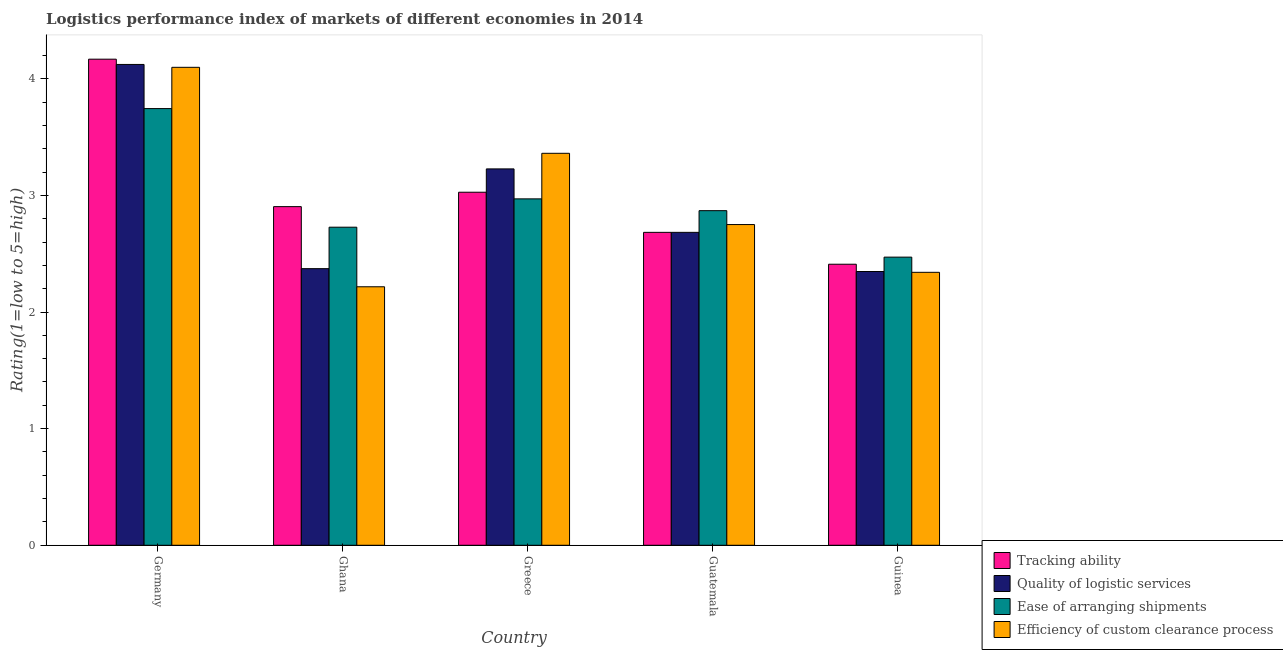How many different coloured bars are there?
Offer a very short reply. 4. Are the number of bars on each tick of the X-axis equal?
Offer a very short reply. Yes. How many bars are there on the 2nd tick from the left?
Give a very brief answer. 4. What is the label of the 5th group of bars from the left?
Your answer should be very brief. Guinea. In how many cases, is the number of bars for a given country not equal to the number of legend labels?
Offer a very short reply. 0. What is the lpi rating of efficiency of custom clearance process in Ghana?
Keep it short and to the point. 2.22. Across all countries, what is the maximum lpi rating of tracking ability?
Your response must be concise. 4.17. Across all countries, what is the minimum lpi rating of quality of logistic services?
Your answer should be compact. 2.35. What is the total lpi rating of quality of logistic services in the graph?
Give a very brief answer. 14.75. What is the difference between the lpi rating of tracking ability in Germany and that in Guatemala?
Give a very brief answer. 1.48. What is the difference between the lpi rating of ease of arranging shipments in Germany and the lpi rating of efficiency of custom clearance process in Guinea?
Your answer should be very brief. 1.4. What is the average lpi rating of quality of logistic services per country?
Provide a succinct answer. 2.95. What is the difference between the lpi rating of ease of arranging shipments and lpi rating of tracking ability in Guinea?
Provide a succinct answer. 0.06. What is the ratio of the lpi rating of ease of arranging shipments in Greece to that in Guinea?
Give a very brief answer. 1.2. Is the lpi rating of tracking ability in Germany less than that in Guinea?
Ensure brevity in your answer.  No. Is the difference between the lpi rating of efficiency of custom clearance process in Germany and Guinea greater than the difference between the lpi rating of quality of logistic services in Germany and Guinea?
Provide a succinct answer. No. What is the difference between the highest and the second highest lpi rating of ease of arranging shipments?
Offer a terse response. 0.77. What is the difference between the highest and the lowest lpi rating of quality of logistic services?
Offer a terse response. 1.78. In how many countries, is the lpi rating of efficiency of custom clearance process greater than the average lpi rating of efficiency of custom clearance process taken over all countries?
Give a very brief answer. 2. Is the sum of the lpi rating of quality of logistic services in Guatemala and Guinea greater than the maximum lpi rating of ease of arranging shipments across all countries?
Give a very brief answer. Yes. Is it the case that in every country, the sum of the lpi rating of quality of logistic services and lpi rating of ease of arranging shipments is greater than the sum of lpi rating of efficiency of custom clearance process and lpi rating of tracking ability?
Your response must be concise. No. What does the 1st bar from the left in Greece represents?
Give a very brief answer. Tracking ability. What does the 1st bar from the right in Greece represents?
Your response must be concise. Efficiency of custom clearance process. Is it the case that in every country, the sum of the lpi rating of tracking ability and lpi rating of quality of logistic services is greater than the lpi rating of ease of arranging shipments?
Ensure brevity in your answer.  Yes. How many bars are there?
Provide a short and direct response. 20. Are all the bars in the graph horizontal?
Provide a succinct answer. No. How many countries are there in the graph?
Your response must be concise. 5. Are the values on the major ticks of Y-axis written in scientific E-notation?
Keep it short and to the point. No. Where does the legend appear in the graph?
Offer a very short reply. Bottom right. How many legend labels are there?
Offer a very short reply. 4. What is the title of the graph?
Make the answer very short. Logistics performance index of markets of different economies in 2014. What is the label or title of the Y-axis?
Your response must be concise. Rating(1=low to 5=high). What is the Rating(1=low to 5=high) of Tracking ability in Germany?
Your answer should be compact. 4.17. What is the Rating(1=low to 5=high) of Quality of logistic services in Germany?
Provide a succinct answer. 4.12. What is the Rating(1=low to 5=high) of Ease of arranging shipments in Germany?
Offer a very short reply. 3.74. What is the Rating(1=low to 5=high) of Efficiency of custom clearance process in Germany?
Provide a succinct answer. 4.1. What is the Rating(1=low to 5=high) in Tracking ability in Ghana?
Provide a short and direct response. 2.9. What is the Rating(1=low to 5=high) in Quality of logistic services in Ghana?
Ensure brevity in your answer.  2.37. What is the Rating(1=low to 5=high) of Ease of arranging shipments in Ghana?
Your answer should be very brief. 2.73. What is the Rating(1=low to 5=high) of Efficiency of custom clearance process in Ghana?
Provide a succinct answer. 2.22. What is the Rating(1=low to 5=high) of Tracking ability in Greece?
Offer a very short reply. 3.03. What is the Rating(1=low to 5=high) of Quality of logistic services in Greece?
Give a very brief answer. 3.23. What is the Rating(1=low to 5=high) of Ease of arranging shipments in Greece?
Your answer should be compact. 2.97. What is the Rating(1=low to 5=high) in Efficiency of custom clearance process in Greece?
Offer a very short reply. 3.36. What is the Rating(1=low to 5=high) in Tracking ability in Guatemala?
Give a very brief answer. 2.68. What is the Rating(1=low to 5=high) of Quality of logistic services in Guatemala?
Provide a short and direct response. 2.68. What is the Rating(1=low to 5=high) of Ease of arranging shipments in Guatemala?
Offer a very short reply. 2.87. What is the Rating(1=low to 5=high) of Efficiency of custom clearance process in Guatemala?
Keep it short and to the point. 2.75. What is the Rating(1=low to 5=high) of Tracking ability in Guinea?
Your response must be concise. 2.41. What is the Rating(1=low to 5=high) of Quality of logistic services in Guinea?
Ensure brevity in your answer.  2.35. What is the Rating(1=low to 5=high) of Ease of arranging shipments in Guinea?
Ensure brevity in your answer.  2.47. What is the Rating(1=low to 5=high) of Efficiency of custom clearance process in Guinea?
Your response must be concise. 2.34. Across all countries, what is the maximum Rating(1=low to 5=high) of Tracking ability?
Make the answer very short. 4.17. Across all countries, what is the maximum Rating(1=low to 5=high) in Quality of logistic services?
Offer a very short reply. 4.12. Across all countries, what is the maximum Rating(1=low to 5=high) in Ease of arranging shipments?
Your response must be concise. 3.74. Across all countries, what is the maximum Rating(1=low to 5=high) of Efficiency of custom clearance process?
Provide a short and direct response. 4.1. Across all countries, what is the minimum Rating(1=low to 5=high) of Tracking ability?
Give a very brief answer. 2.41. Across all countries, what is the minimum Rating(1=low to 5=high) in Quality of logistic services?
Keep it short and to the point. 2.35. Across all countries, what is the minimum Rating(1=low to 5=high) of Ease of arranging shipments?
Offer a terse response. 2.47. Across all countries, what is the minimum Rating(1=low to 5=high) of Efficiency of custom clearance process?
Your answer should be very brief. 2.22. What is the total Rating(1=low to 5=high) in Tracking ability in the graph?
Your answer should be very brief. 15.19. What is the total Rating(1=low to 5=high) of Quality of logistic services in the graph?
Give a very brief answer. 14.75. What is the total Rating(1=low to 5=high) in Ease of arranging shipments in the graph?
Your response must be concise. 14.78. What is the total Rating(1=low to 5=high) in Efficiency of custom clearance process in the graph?
Offer a terse response. 14.77. What is the difference between the Rating(1=low to 5=high) of Tracking ability in Germany and that in Ghana?
Give a very brief answer. 1.26. What is the difference between the Rating(1=low to 5=high) of Quality of logistic services in Germany and that in Ghana?
Your answer should be compact. 1.75. What is the difference between the Rating(1=low to 5=high) in Ease of arranging shipments in Germany and that in Ghana?
Offer a terse response. 1.02. What is the difference between the Rating(1=low to 5=high) in Efficiency of custom clearance process in Germany and that in Ghana?
Your answer should be compact. 1.88. What is the difference between the Rating(1=low to 5=high) in Tracking ability in Germany and that in Greece?
Your answer should be compact. 1.14. What is the difference between the Rating(1=low to 5=high) in Quality of logistic services in Germany and that in Greece?
Provide a succinct answer. 0.9. What is the difference between the Rating(1=low to 5=high) of Ease of arranging shipments in Germany and that in Greece?
Offer a very short reply. 0.77. What is the difference between the Rating(1=low to 5=high) in Efficiency of custom clearance process in Germany and that in Greece?
Provide a succinct answer. 0.74. What is the difference between the Rating(1=low to 5=high) in Tracking ability in Germany and that in Guatemala?
Make the answer very short. 1.48. What is the difference between the Rating(1=low to 5=high) in Quality of logistic services in Germany and that in Guatemala?
Your response must be concise. 1.44. What is the difference between the Rating(1=low to 5=high) in Ease of arranging shipments in Germany and that in Guatemala?
Give a very brief answer. 0.88. What is the difference between the Rating(1=low to 5=high) in Efficiency of custom clearance process in Germany and that in Guatemala?
Provide a succinct answer. 1.35. What is the difference between the Rating(1=low to 5=high) of Tracking ability in Germany and that in Guinea?
Keep it short and to the point. 1.76. What is the difference between the Rating(1=low to 5=high) of Quality of logistic services in Germany and that in Guinea?
Provide a succinct answer. 1.78. What is the difference between the Rating(1=low to 5=high) of Ease of arranging shipments in Germany and that in Guinea?
Give a very brief answer. 1.27. What is the difference between the Rating(1=low to 5=high) in Efficiency of custom clearance process in Germany and that in Guinea?
Offer a terse response. 1.76. What is the difference between the Rating(1=low to 5=high) of Tracking ability in Ghana and that in Greece?
Ensure brevity in your answer.  -0.12. What is the difference between the Rating(1=low to 5=high) in Quality of logistic services in Ghana and that in Greece?
Offer a very short reply. -0.86. What is the difference between the Rating(1=low to 5=high) of Ease of arranging shipments in Ghana and that in Greece?
Your answer should be compact. -0.24. What is the difference between the Rating(1=low to 5=high) in Efficiency of custom clearance process in Ghana and that in Greece?
Your answer should be very brief. -1.14. What is the difference between the Rating(1=low to 5=high) in Tracking ability in Ghana and that in Guatemala?
Your response must be concise. 0.22. What is the difference between the Rating(1=low to 5=high) in Quality of logistic services in Ghana and that in Guatemala?
Provide a succinct answer. -0.31. What is the difference between the Rating(1=low to 5=high) of Ease of arranging shipments in Ghana and that in Guatemala?
Give a very brief answer. -0.14. What is the difference between the Rating(1=low to 5=high) in Efficiency of custom clearance process in Ghana and that in Guatemala?
Provide a succinct answer. -0.53. What is the difference between the Rating(1=low to 5=high) of Tracking ability in Ghana and that in Guinea?
Your answer should be compact. 0.49. What is the difference between the Rating(1=low to 5=high) in Quality of logistic services in Ghana and that in Guinea?
Your response must be concise. 0.02. What is the difference between the Rating(1=low to 5=high) of Ease of arranging shipments in Ghana and that in Guinea?
Your response must be concise. 0.26. What is the difference between the Rating(1=low to 5=high) of Efficiency of custom clearance process in Ghana and that in Guinea?
Ensure brevity in your answer.  -0.12. What is the difference between the Rating(1=low to 5=high) of Tracking ability in Greece and that in Guatemala?
Provide a short and direct response. 0.34. What is the difference between the Rating(1=low to 5=high) of Quality of logistic services in Greece and that in Guatemala?
Offer a terse response. 0.54. What is the difference between the Rating(1=low to 5=high) of Ease of arranging shipments in Greece and that in Guatemala?
Ensure brevity in your answer.  0.1. What is the difference between the Rating(1=low to 5=high) of Efficiency of custom clearance process in Greece and that in Guatemala?
Your response must be concise. 0.61. What is the difference between the Rating(1=low to 5=high) in Tracking ability in Greece and that in Guinea?
Make the answer very short. 0.62. What is the difference between the Rating(1=low to 5=high) of Quality of logistic services in Greece and that in Guinea?
Your response must be concise. 0.88. What is the difference between the Rating(1=low to 5=high) in Ease of arranging shipments in Greece and that in Guinea?
Your response must be concise. 0.5. What is the difference between the Rating(1=low to 5=high) of Efficiency of custom clearance process in Greece and that in Guinea?
Offer a terse response. 1.02. What is the difference between the Rating(1=low to 5=high) in Tracking ability in Guatemala and that in Guinea?
Your answer should be compact. 0.27. What is the difference between the Rating(1=low to 5=high) of Quality of logistic services in Guatemala and that in Guinea?
Your response must be concise. 0.34. What is the difference between the Rating(1=low to 5=high) in Ease of arranging shipments in Guatemala and that in Guinea?
Provide a succinct answer. 0.4. What is the difference between the Rating(1=low to 5=high) in Efficiency of custom clearance process in Guatemala and that in Guinea?
Offer a terse response. 0.41. What is the difference between the Rating(1=low to 5=high) in Tracking ability in Germany and the Rating(1=low to 5=high) in Quality of logistic services in Ghana?
Provide a succinct answer. 1.8. What is the difference between the Rating(1=low to 5=high) in Tracking ability in Germany and the Rating(1=low to 5=high) in Ease of arranging shipments in Ghana?
Provide a short and direct response. 1.44. What is the difference between the Rating(1=low to 5=high) of Tracking ability in Germany and the Rating(1=low to 5=high) of Efficiency of custom clearance process in Ghana?
Keep it short and to the point. 1.95. What is the difference between the Rating(1=low to 5=high) of Quality of logistic services in Germany and the Rating(1=low to 5=high) of Ease of arranging shipments in Ghana?
Offer a very short reply. 1.4. What is the difference between the Rating(1=low to 5=high) of Quality of logistic services in Germany and the Rating(1=low to 5=high) of Efficiency of custom clearance process in Ghana?
Ensure brevity in your answer.  1.91. What is the difference between the Rating(1=low to 5=high) in Ease of arranging shipments in Germany and the Rating(1=low to 5=high) in Efficiency of custom clearance process in Ghana?
Ensure brevity in your answer.  1.53. What is the difference between the Rating(1=low to 5=high) in Tracking ability in Germany and the Rating(1=low to 5=high) in Quality of logistic services in Greece?
Offer a very short reply. 0.94. What is the difference between the Rating(1=low to 5=high) in Tracking ability in Germany and the Rating(1=low to 5=high) in Ease of arranging shipments in Greece?
Make the answer very short. 1.2. What is the difference between the Rating(1=low to 5=high) in Tracking ability in Germany and the Rating(1=low to 5=high) in Efficiency of custom clearance process in Greece?
Your answer should be very brief. 0.81. What is the difference between the Rating(1=low to 5=high) of Quality of logistic services in Germany and the Rating(1=low to 5=high) of Ease of arranging shipments in Greece?
Keep it short and to the point. 1.15. What is the difference between the Rating(1=low to 5=high) of Quality of logistic services in Germany and the Rating(1=low to 5=high) of Efficiency of custom clearance process in Greece?
Your response must be concise. 0.76. What is the difference between the Rating(1=low to 5=high) of Ease of arranging shipments in Germany and the Rating(1=low to 5=high) of Efficiency of custom clearance process in Greece?
Provide a succinct answer. 0.38. What is the difference between the Rating(1=low to 5=high) in Tracking ability in Germany and the Rating(1=low to 5=high) in Quality of logistic services in Guatemala?
Your answer should be compact. 1.48. What is the difference between the Rating(1=low to 5=high) in Tracking ability in Germany and the Rating(1=low to 5=high) in Ease of arranging shipments in Guatemala?
Provide a succinct answer. 1.3. What is the difference between the Rating(1=low to 5=high) in Tracking ability in Germany and the Rating(1=low to 5=high) in Efficiency of custom clearance process in Guatemala?
Your answer should be very brief. 1.42. What is the difference between the Rating(1=low to 5=high) of Quality of logistic services in Germany and the Rating(1=low to 5=high) of Ease of arranging shipments in Guatemala?
Your answer should be very brief. 1.25. What is the difference between the Rating(1=low to 5=high) in Quality of logistic services in Germany and the Rating(1=low to 5=high) in Efficiency of custom clearance process in Guatemala?
Your answer should be very brief. 1.37. What is the difference between the Rating(1=low to 5=high) of Tracking ability in Germany and the Rating(1=low to 5=high) of Quality of logistic services in Guinea?
Offer a terse response. 1.82. What is the difference between the Rating(1=low to 5=high) in Tracking ability in Germany and the Rating(1=low to 5=high) in Ease of arranging shipments in Guinea?
Make the answer very short. 1.7. What is the difference between the Rating(1=low to 5=high) of Tracking ability in Germany and the Rating(1=low to 5=high) of Efficiency of custom clearance process in Guinea?
Keep it short and to the point. 1.83. What is the difference between the Rating(1=low to 5=high) of Quality of logistic services in Germany and the Rating(1=low to 5=high) of Ease of arranging shipments in Guinea?
Your answer should be compact. 1.65. What is the difference between the Rating(1=low to 5=high) in Quality of logistic services in Germany and the Rating(1=low to 5=high) in Efficiency of custom clearance process in Guinea?
Ensure brevity in your answer.  1.78. What is the difference between the Rating(1=low to 5=high) in Ease of arranging shipments in Germany and the Rating(1=low to 5=high) in Efficiency of custom clearance process in Guinea?
Keep it short and to the point. 1.4. What is the difference between the Rating(1=low to 5=high) in Tracking ability in Ghana and the Rating(1=low to 5=high) in Quality of logistic services in Greece?
Offer a terse response. -0.32. What is the difference between the Rating(1=low to 5=high) in Tracking ability in Ghana and the Rating(1=low to 5=high) in Ease of arranging shipments in Greece?
Make the answer very short. -0.07. What is the difference between the Rating(1=low to 5=high) in Tracking ability in Ghana and the Rating(1=low to 5=high) in Efficiency of custom clearance process in Greece?
Ensure brevity in your answer.  -0.46. What is the difference between the Rating(1=low to 5=high) of Quality of logistic services in Ghana and the Rating(1=low to 5=high) of Ease of arranging shipments in Greece?
Offer a terse response. -0.6. What is the difference between the Rating(1=low to 5=high) in Quality of logistic services in Ghana and the Rating(1=low to 5=high) in Efficiency of custom clearance process in Greece?
Make the answer very short. -0.99. What is the difference between the Rating(1=low to 5=high) in Ease of arranging shipments in Ghana and the Rating(1=low to 5=high) in Efficiency of custom clearance process in Greece?
Give a very brief answer. -0.63. What is the difference between the Rating(1=low to 5=high) of Tracking ability in Ghana and the Rating(1=low to 5=high) of Quality of logistic services in Guatemala?
Give a very brief answer. 0.22. What is the difference between the Rating(1=low to 5=high) of Tracking ability in Ghana and the Rating(1=low to 5=high) of Ease of arranging shipments in Guatemala?
Provide a short and direct response. 0.03. What is the difference between the Rating(1=low to 5=high) in Tracking ability in Ghana and the Rating(1=low to 5=high) in Efficiency of custom clearance process in Guatemala?
Offer a terse response. 0.15. What is the difference between the Rating(1=low to 5=high) in Quality of logistic services in Ghana and the Rating(1=low to 5=high) in Ease of arranging shipments in Guatemala?
Give a very brief answer. -0.5. What is the difference between the Rating(1=low to 5=high) of Quality of logistic services in Ghana and the Rating(1=low to 5=high) of Efficiency of custom clearance process in Guatemala?
Offer a terse response. -0.38. What is the difference between the Rating(1=low to 5=high) of Ease of arranging shipments in Ghana and the Rating(1=low to 5=high) of Efficiency of custom clearance process in Guatemala?
Provide a short and direct response. -0.02. What is the difference between the Rating(1=low to 5=high) in Tracking ability in Ghana and the Rating(1=low to 5=high) in Quality of logistic services in Guinea?
Give a very brief answer. 0.56. What is the difference between the Rating(1=low to 5=high) of Tracking ability in Ghana and the Rating(1=low to 5=high) of Ease of arranging shipments in Guinea?
Keep it short and to the point. 0.43. What is the difference between the Rating(1=low to 5=high) in Tracking ability in Ghana and the Rating(1=low to 5=high) in Efficiency of custom clearance process in Guinea?
Provide a succinct answer. 0.56. What is the difference between the Rating(1=low to 5=high) in Quality of logistic services in Ghana and the Rating(1=low to 5=high) in Ease of arranging shipments in Guinea?
Provide a short and direct response. -0.1. What is the difference between the Rating(1=low to 5=high) in Quality of logistic services in Ghana and the Rating(1=low to 5=high) in Efficiency of custom clearance process in Guinea?
Your response must be concise. 0.03. What is the difference between the Rating(1=low to 5=high) in Ease of arranging shipments in Ghana and the Rating(1=low to 5=high) in Efficiency of custom clearance process in Guinea?
Give a very brief answer. 0.39. What is the difference between the Rating(1=low to 5=high) in Tracking ability in Greece and the Rating(1=low to 5=high) in Quality of logistic services in Guatemala?
Keep it short and to the point. 0.34. What is the difference between the Rating(1=low to 5=high) of Tracking ability in Greece and the Rating(1=low to 5=high) of Ease of arranging shipments in Guatemala?
Offer a terse response. 0.16. What is the difference between the Rating(1=low to 5=high) in Tracking ability in Greece and the Rating(1=low to 5=high) in Efficiency of custom clearance process in Guatemala?
Provide a succinct answer. 0.28. What is the difference between the Rating(1=low to 5=high) in Quality of logistic services in Greece and the Rating(1=low to 5=high) in Ease of arranging shipments in Guatemala?
Your answer should be compact. 0.36. What is the difference between the Rating(1=low to 5=high) in Quality of logistic services in Greece and the Rating(1=low to 5=high) in Efficiency of custom clearance process in Guatemala?
Provide a succinct answer. 0.48. What is the difference between the Rating(1=low to 5=high) in Ease of arranging shipments in Greece and the Rating(1=low to 5=high) in Efficiency of custom clearance process in Guatemala?
Provide a succinct answer. 0.22. What is the difference between the Rating(1=low to 5=high) in Tracking ability in Greece and the Rating(1=low to 5=high) in Quality of logistic services in Guinea?
Your answer should be compact. 0.68. What is the difference between the Rating(1=low to 5=high) of Tracking ability in Greece and the Rating(1=low to 5=high) of Ease of arranging shipments in Guinea?
Make the answer very short. 0.56. What is the difference between the Rating(1=low to 5=high) of Tracking ability in Greece and the Rating(1=low to 5=high) of Efficiency of custom clearance process in Guinea?
Offer a terse response. 0.69. What is the difference between the Rating(1=low to 5=high) in Quality of logistic services in Greece and the Rating(1=low to 5=high) in Ease of arranging shipments in Guinea?
Your response must be concise. 0.76. What is the difference between the Rating(1=low to 5=high) of Quality of logistic services in Greece and the Rating(1=low to 5=high) of Efficiency of custom clearance process in Guinea?
Provide a short and direct response. 0.89. What is the difference between the Rating(1=low to 5=high) in Ease of arranging shipments in Greece and the Rating(1=low to 5=high) in Efficiency of custom clearance process in Guinea?
Offer a terse response. 0.63. What is the difference between the Rating(1=low to 5=high) of Tracking ability in Guatemala and the Rating(1=low to 5=high) of Quality of logistic services in Guinea?
Offer a terse response. 0.34. What is the difference between the Rating(1=low to 5=high) in Tracking ability in Guatemala and the Rating(1=low to 5=high) in Ease of arranging shipments in Guinea?
Ensure brevity in your answer.  0.21. What is the difference between the Rating(1=low to 5=high) in Tracking ability in Guatemala and the Rating(1=low to 5=high) in Efficiency of custom clearance process in Guinea?
Offer a very short reply. 0.34. What is the difference between the Rating(1=low to 5=high) of Quality of logistic services in Guatemala and the Rating(1=low to 5=high) of Ease of arranging shipments in Guinea?
Make the answer very short. 0.21. What is the difference between the Rating(1=low to 5=high) in Quality of logistic services in Guatemala and the Rating(1=low to 5=high) in Efficiency of custom clearance process in Guinea?
Make the answer very short. 0.34. What is the difference between the Rating(1=low to 5=high) in Ease of arranging shipments in Guatemala and the Rating(1=low to 5=high) in Efficiency of custom clearance process in Guinea?
Make the answer very short. 0.53. What is the average Rating(1=low to 5=high) of Tracking ability per country?
Provide a short and direct response. 3.04. What is the average Rating(1=low to 5=high) of Quality of logistic services per country?
Make the answer very short. 2.95. What is the average Rating(1=low to 5=high) in Ease of arranging shipments per country?
Your response must be concise. 2.96. What is the average Rating(1=low to 5=high) in Efficiency of custom clearance process per country?
Keep it short and to the point. 2.95. What is the difference between the Rating(1=low to 5=high) of Tracking ability and Rating(1=low to 5=high) of Quality of logistic services in Germany?
Provide a short and direct response. 0.05. What is the difference between the Rating(1=low to 5=high) of Tracking ability and Rating(1=low to 5=high) of Ease of arranging shipments in Germany?
Ensure brevity in your answer.  0.42. What is the difference between the Rating(1=low to 5=high) of Tracking ability and Rating(1=low to 5=high) of Efficiency of custom clearance process in Germany?
Your answer should be very brief. 0.07. What is the difference between the Rating(1=low to 5=high) of Quality of logistic services and Rating(1=low to 5=high) of Ease of arranging shipments in Germany?
Provide a short and direct response. 0.38. What is the difference between the Rating(1=low to 5=high) in Quality of logistic services and Rating(1=low to 5=high) in Efficiency of custom clearance process in Germany?
Offer a very short reply. 0.02. What is the difference between the Rating(1=low to 5=high) in Ease of arranging shipments and Rating(1=low to 5=high) in Efficiency of custom clearance process in Germany?
Make the answer very short. -0.35. What is the difference between the Rating(1=low to 5=high) of Tracking ability and Rating(1=low to 5=high) of Quality of logistic services in Ghana?
Ensure brevity in your answer.  0.53. What is the difference between the Rating(1=low to 5=high) of Tracking ability and Rating(1=low to 5=high) of Ease of arranging shipments in Ghana?
Your response must be concise. 0.18. What is the difference between the Rating(1=low to 5=high) of Tracking ability and Rating(1=low to 5=high) of Efficiency of custom clearance process in Ghana?
Give a very brief answer. 0.69. What is the difference between the Rating(1=low to 5=high) in Quality of logistic services and Rating(1=low to 5=high) in Ease of arranging shipments in Ghana?
Keep it short and to the point. -0.36. What is the difference between the Rating(1=low to 5=high) in Quality of logistic services and Rating(1=low to 5=high) in Efficiency of custom clearance process in Ghana?
Make the answer very short. 0.16. What is the difference between the Rating(1=low to 5=high) in Ease of arranging shipments and Rating(1=low to 5=high) in Efficiency of custom clearance process in Ghana?
Give a very brief answer. 0.51. What is the difference between the Rating(1=low to 5=high) of Tracking ability and Rating(1=low to 5=high) of Ease of arranging shipments in Greece?
Keep it short and to the point. 0.06. What is the difference between the Rating(1=low to 5=high) in Tracking ability and Rating(1=low to 5=high) in Efficiency of custom clearance process in Greece?
Ensure brevity in your answer.  -0.33. What is the difference between the Rating(1=low to 5=high) of Quality of logistic services and Rating(1=low to 5=high) of Ease of arranging shipments in Greece?
Offer a terse response. 0.26. What is the difference between the Rating(1=low to 5=high) of Quality of logistic services and Rating(1=low to 5=high) of Efficiency of custom clearance process in Greece?
Provide a short and direct response. -0.13. What is the difference between the Rating(1=low to 5=high) of Ease of arranging shipments and Rating(1=low to 5=high) of Efficiency of custom clearance process in Greece?
Ensure brevity in your answer.  -0.39. What is the difference between the Rating(1=low to 5=high) in Tracking ability and Rating(1=low to 5=high) in Quality of logistic services in Guatemala?
Make the answer very short. 0. What is the difference between the Rating(1=low to 5=high) in Tracking ability and Rating(1=low to 5=high) in Ease of arranging shipments in Guatemala?
Provide a short and direct response. -0.19. What is the difference between the Rating(1=low to 5=high) of Tracking ability and Rating(1=low to 5=high) of Efficiency of custom clearance process in Guatemala?
Your response must be concise. -0.07. What is the difference between the Rating(1=low to 5=high) in Quality of logistic services and Rating(1=low to 5=high) in Ease of arranging shipments in Guatemala?
Offer a very short reply. -0.19. What is the difference between the Rating(1=low to 5=high) of Quality of logistic services and Rating(1=low to 5=high) of Efficiency of custom clearance process in Guatemala?
Ensure brevity in your answer.  -0.07. What is the difference between the Rating(1=low to 5=high) in Ease of arranging shipments and Rating(1=low to 5=high) in Efficiency of custom clearance process in Guatemala?
Offer a very short reply. 0.12. What is the difference between the Rating(1=low to 5=high) of Tracking ability and Rating(1=low to 5=high) of Quality of logistic services in Guinea?
Ensure brevity in your answer.  0.06. What is the difference between the Rating(1=low to 5=high) in Tracking ability and Rating(1=low to 5=high) in Ease of arranging shipments in Guinea?
Make the answer very short. -0.06. What is the difference between the Rating(1=low to 5=high) of Tracking ability and Rating(1=low to 5=high) of Efficiency of custom clearance process in Guinea?
Offer a very short reply. 0.07. What is the difference between the Rating(1=low to 5=high) of Quality of logistic services and Rating(1=low to 5=high) of Ease of arranging shipments in Guinea?
Provide a short and direct response. -0.12. What is the difference between the Rating(1=low to 5=high) in Quality of logistic services and Rating(1=low to 5=high) in Efficiency of custom clearance process in Guinea?
Your answer should be compact. 0.01. What is the difference between the Rating(1=low to 5=high) in Ease of arranging shipments and Rating(1=low to 5=high) in Efficiency of custom clearance process in Guinea?
Provide a succinct answer. 0.13. What is the ratio of the Rating(1=low to 5=high) in Tracking ability in Germany to that in Ghana?
Offer a very short reply. 1.44. What is the ratio of the Rating(1=low to 5=high) of Quality of logistic services in Germany to that in Ghana?
Give a very brief answer. 1.74. What is the ratio of the Rating(1=low to 5=high) in Ease of arranging shipments in Germany to that in Ghana?
Offer a terse response. 1.37. What is the ratio of the Rating(1=low to 5=high) of Efficiency of custom clearance process in Germany to that in Ghana?
Provide a succinct answer. 1.85. What is the ratio of the Rating(1=low to 5=high) in Tracking ability in Germany to that in Greece?
Give a very brief answer. 1.38. What is the ratio of the Rating(1=low to 5=high) in Quality of logistic services in Germany to that in Greece?
Offer a very short reply. 1.28. What is the ratio of the Rating(1=low to 5=high) of Ease of arranging shipments in Germany to that in Greece?
Provide a short and direct response. 1.26. What is the ratio of the Rating(1=low to 5=high) in Efficiency of custom clearance process in Germany to that in Greece?
Ensure brevity in your answer.  1.22. What is the ratio of the Rating(1=low to 5=high) of Tracking ability in Germany to that in Guatemala?
Offer a very short reply. 1.55. What is the ratio of the Rating(1=low to 5=high) of Quality of logistic services in Germany to that in Guatemala?
Provide a succinct answer. 1.54. What is the ratio of the Rating(1=low to 5=high) in Ease of arranging shipments in Germany to that in Guatemala?
Your answer should be compact. 1.31. What is the ratio of the Rating(1=low to 5=high) of Efficiency of custom clearance process in Germany to that in Guatemala?
Your answer should be compact. 1.49. What is the ratio of the Rating(1=low to 5=high) of Tracking ability in Germany to that in Guinea?
Your answer should be very brief. 1.73. What is the ratio of the Rating(1=low to 5=high) in Quality of logistic services in Germany to that in Guinea?
Your answer should be compact. 1.76. What is the ratio of the Rating(1=low to 5=high) of Ease of arranging shipments in Germany to that in Guinea?
Your answer should be very brief. 1.52. What is the ratio of the Rating(1=low to 5=high) of Efficiency of custom clearance process in Germany to that in Guinea?
Your answer should be compact. 1.75. What is the ratio of the Rating(1=low to 5=high) in Tracking ability in Ghana to that in Greece?
Give a very brief answer. 0.96. What is the ratio of the Rating(1=low to 5=high) of Quality of logistic services in Ghana to that in Greece?
Your response must be concise. 0.73. What is the ratio of the Rating(1=low to 5=high) of Ease of arranging shipments in Ghana to that in Greece?
Make the answer very short. 0.92. What is the ratio of the Rating(1=low to 5=high) in Efficiency of custom clearance process in Ghana to that in Greece?
Give a very brief answer. 0.66. What is the ratio of the Rating(1=low to 5=high) of Tracking ability in Ghana to that in Guatemala?
Ensure brevity in your answer.  1.08. What is the ratio of the Rating(1=low to 5=high) in Quality of logistic services in Ghana to that in Guatemala?
Your answer should be compact. 0.88. What is the ratio of the Rating(1=low to 5=high) in Ease of arranging shipments in Ghana to that in Guatemala?
Your answer should be compact. 0.95. What is the ratio of the Rating(1=low to 5=high) in Efficiency of custom clearance process in Ghana to that in Guatemala?
Offer a very short reply. 0.81. What is the ratio of the Rating(1=low to 5=high) in Tracking ability in Ghana to that in Guinea?
Your response must be concise. 1.2. What is the ratio of the Rating(1=low to 5=high) of Quality of logistic services in Ghana to that in Guinea?
Provide a short and direct response. 1.01. What is the ratio of the Rating(1=low to 5=high) of Ease of arranging shipments in Ghana to that in Guinea?
Provide a succinct answer. 1.1. What is the ratio of the Rating(1=low to 5=high) of Efficiency of custom clearance process in Ghana to that in Guinea?
Ensure brevity in your answer.  0.95. What is the ratio of the Rating(1=low to 5=high) of Tracking ability in Greece to that in Guatemala?
Keep it short and to the point. 1.13. What is the ratio of the Rating(1=low to 5=high) in Quality of logistic services in Greece to that in Guatemala?
Offer a terse response. 1.2. What is the ratio of the Rating(1=low to 5=high) of Ease of arranging shipments in Greece to that in Guatemala?
Provide a short and direct response. 1.04. What is the ratio of the Rating(1=low to 5=high) of Efficiency of custom clearance process in Greece to that in Guatemala?
Provide a short and direct response. 1.22. What is the ratio of the Rating(1=low to 5=high) in Tracking ability in Greece to that in Guinea?
Offer a terse response. 1.26. What is the ratio of the Rating(1=low to 5=high) in Quality of logistic services in Greece to that in Guinea?
Your answer should be very brief. 1.37. What is the ratio of the Rating(1=low to 5=high) in Ease of arranging shipments in Greece to that in Guinea?
Offer a terse response. 1.2. What is the ratio of the Rating(1=low to 5=high) in Efficiency of custom clearance process in Greece to that in Guinea?
Make the answer very short. 1.44. What is the ratio of the Rating(1=low to 5=high) of Tracking ability in Guatemala to that in Guinea?
Ensure brevity in your answer.  1.11. What is the ratio of the Rating(1=low to 5=high) of Quality of logistic services in Guatemala to that in Guinea?
Your answer should be compact. 1.14. What is the ratio of the Rating(1=low to 5=high) in Ease of arranging shipments in Guatemala to that in Guinea?
Your response must be concise. 1.16. What is the ratio of the Rating(1=low to 5=high) of Efficiency of custom clearance process in Guatemala to that in Guinea?
Provide a succinct answer. 1.18. What is the difference between the highest and the second highest Rating(1=low to 5=high) of Tracking ability?
Provide a succinct answer. 1.14. What is the difference between the highest and the second highest Rating(1=low to 5=high) in Quality of logistic services?
Your answer should be compact. 0.9. What is the difference between the highest and the second highest Rating(1=low to 5=high) in Ease of arranging shipments?
Your answer should be compact. 0.77. What is the difference between the highest and the second highest Rating(1=low to 5=high) of Efficiency of custom clearance process?
Offer a terse response. 0.74. What is the difference between the highest and the lowest Rating(1=low to 5=high) in Tracking ability?
Your response must be concise. 1.76. What is the difference between the highest and the lowest Rating(1=low to 5=high) of Quality of logistic services?
Offer a very short reply. 1.78. What is the difference between the highest and the lowest Rating(1=low to 5=high) in Ease of arranging shipments?
Make the answer very short. 1.27. What is the difference between the highest and the lowest Rating(1=low to 5=high) of Efficiency of custom clearance process?
Provide a short and direct response. 1.88. 